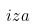<formula> <loc_0><loc_0><loc_500><loc_500>i z a</formula> 